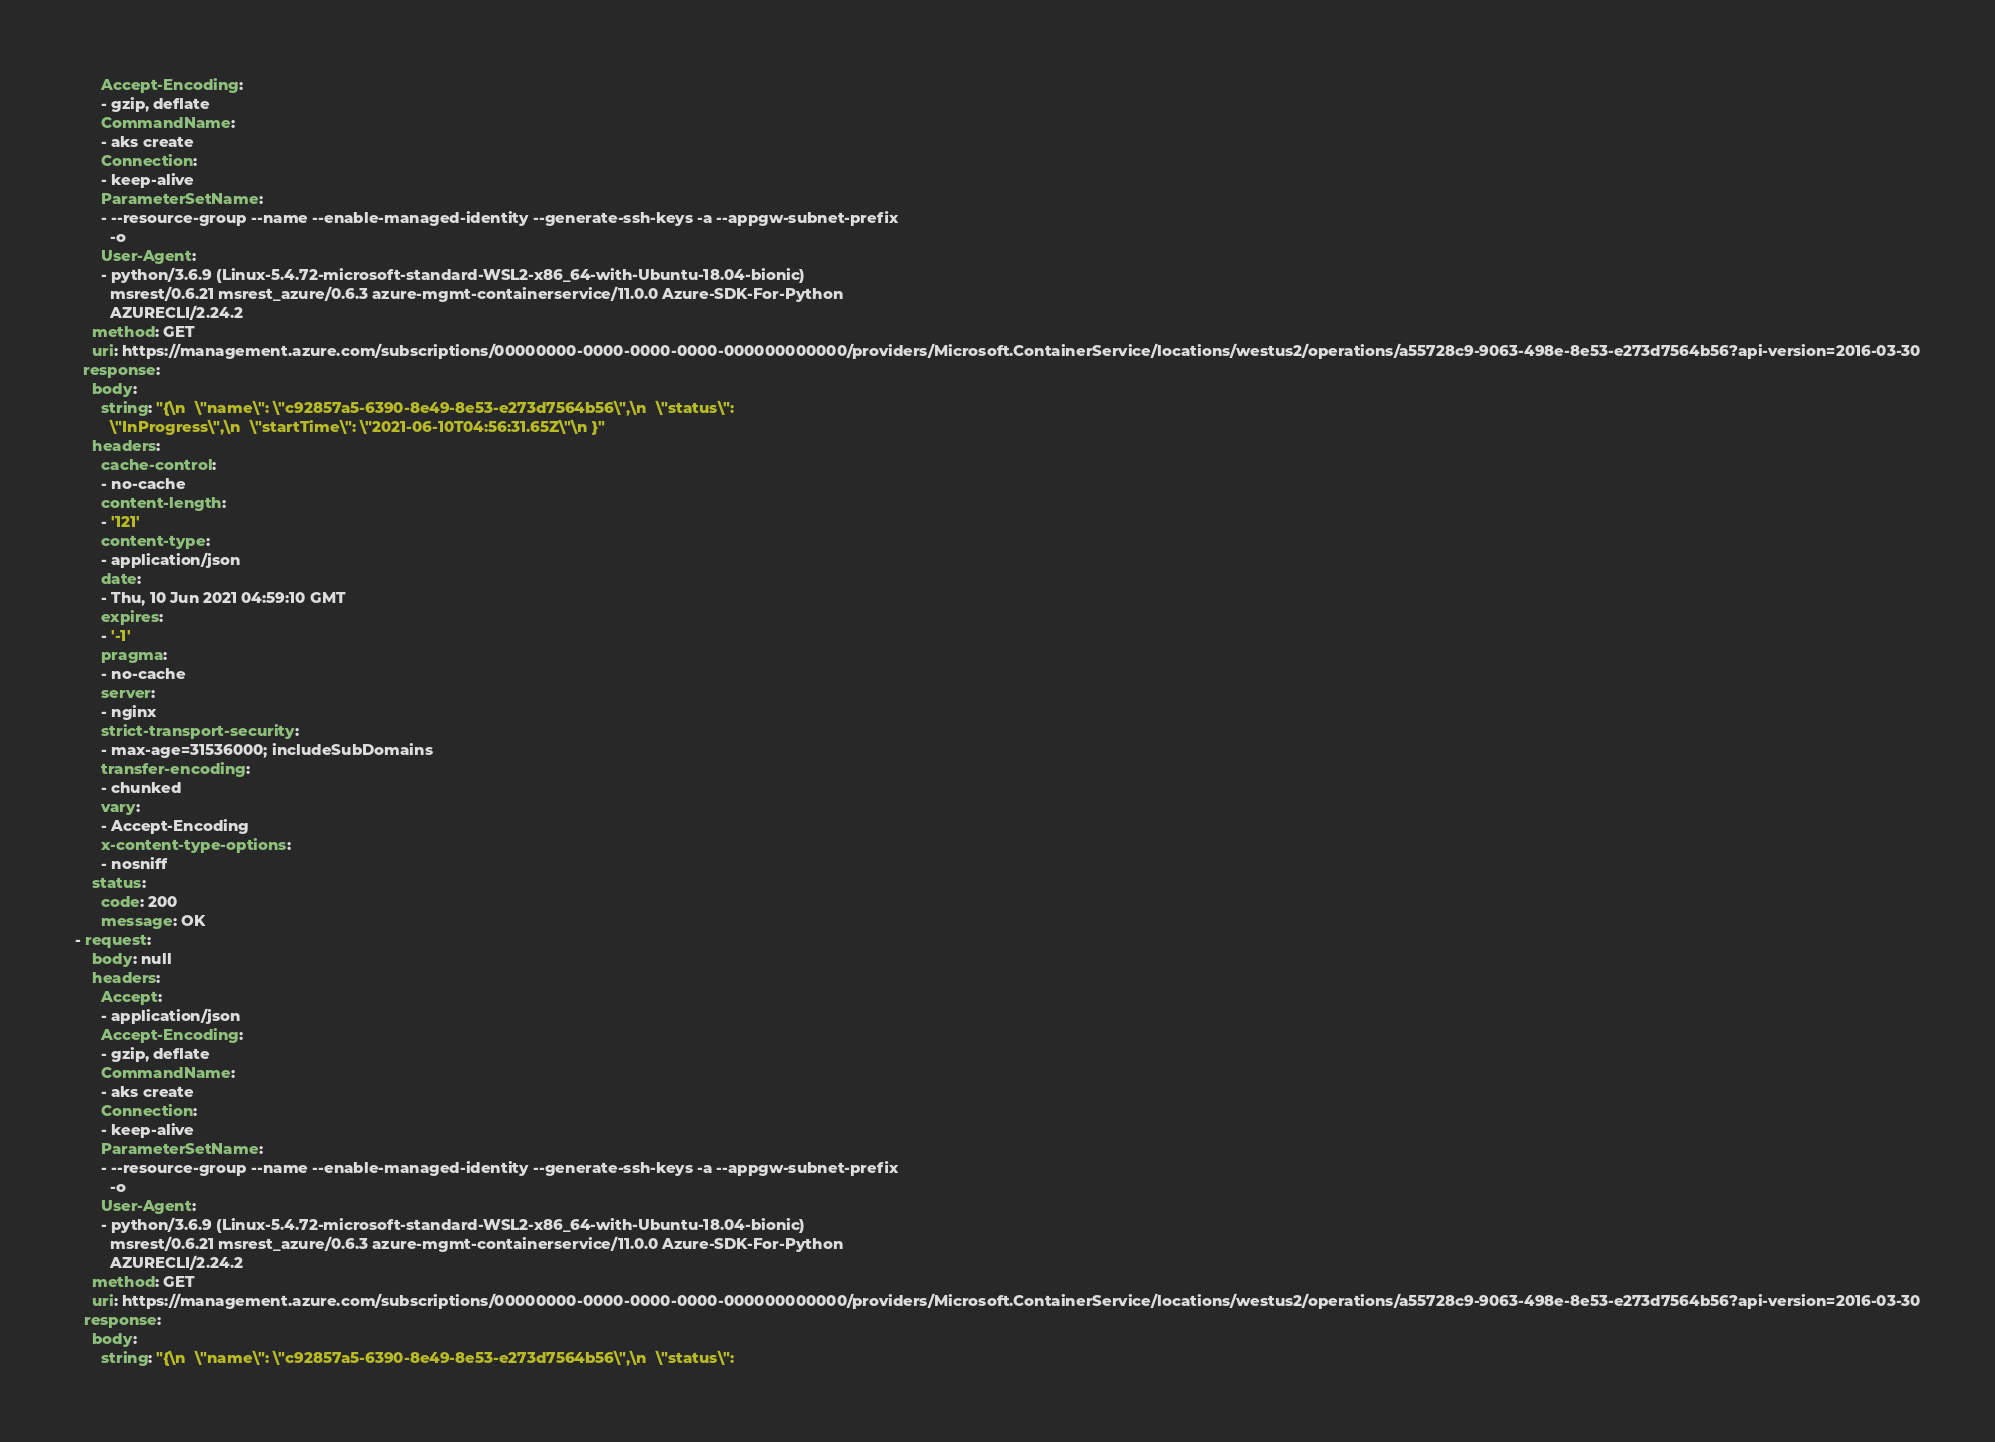<code> <loc_0><loc_0><loc_500><loc_500><_YAML_>      Accept-Encoding:
      - gzip, deflate
      CommandName:
      - aks create
      Connection:
      - keep-alive
      ParameterSetName:
      - --resource-group --name --enable-managed-identity --generate-ssh-keys -a --appgw-subnet-prefix
        -o
      User-Agent:
      - python/3.6.9 (Linux-5.4.72-microsoft-standard-WSL2-x86_64-with-Ubuntu-18.04-bionic)
        msrest/0.6.21 msrest_azure/0.6.3 azure-mgmt-containerservice/11.0.0 Azure-SDK-For-Python
        AZURECLI/2.24.2
    method: GET
    uri: https://management.azure.com/subscriptions/00000000-0000-0000-0000-000000000000/providers/Microsoft.ContainerService/locations/westus2/operations/a55728c9-9063-498e-8e53-e273d7564b56?api-version=2016-03-30
  response:
    body:
      string: "{\n  \"name\": \"c92857a5-6390-8e49-8e53-e273d7564b56\",\n  \"status\":
        \"InProgress\",\n  \"startTime\": \"2021-06-10T04:56:31.65Z\"\n }"
    headers:
      cache-control:
      - no-cache
      content-length:
      - '121'
      content-type:
      - application/json
      date:
      - Thu, 10 Jun 2021 04:59:10 GMT
      expires:
      - '-1'
      pragma:
      - no-cache
      server:
      - nginx
      strict-transport-security:
      - max-age=31536000; includeSubDomains
      transfer-encoding:
      - chunked
      vary:
      - Accept-Encoding
      x-content-type-options:
      - nosniff
    status:
      code: 200
      message: OK
- request:
    body: null
    headers:
      Accept:
      - application/json
      Accept-Encoding:
      - gzip, deflate
      CommandName:
      - aks create
      Connection:
      - keep-alive
      ParameterSetName:
      - --resource-group --name --enable-managed-identity --generate-ssh-keys -a --appgw-subnet-prefix
        -o
      User-Agent:
      - python/3.6.9 (Linux-5.4.72-microsoft-standard-WSL2-x86_64-with-Ubuntu-18.04-bionic)
        msrest/0.6.21 msrest_azure/0.6.3 azure-mgmt-containerservice/11.0.0 Azure-SDK-For-Python
        AZURECLI/2.24.2
    method: GET
    uri: https://management.azure.com/subscriptions/00000000-0000-0000-0000-000000000000/providers/Microsoft.ContainerService/locations/westus2/operations/a55728c9-9063-498e-8e53-e273d7564b56?api-version=2016-03-30
  response:
    body:
      string: "{\n  \"name\": \"c92857a5-6390-8e49-8e53-e273d7564b56\",\n  \"status\":</code> 